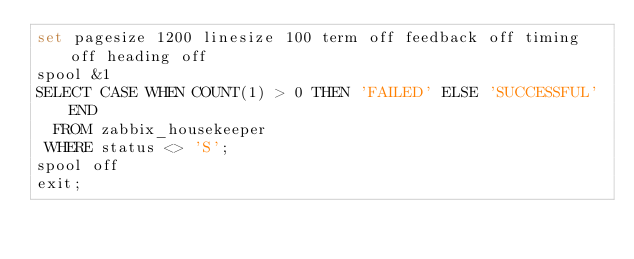Convert code to text. <code><loc_0><loc_0><loc_500><loc_500><_SQL_>set pagesize 1200 linesize 100 term off feedback off timing off heading off
spool &1
SELECT CASE WHEN COUNT(1) > 0 THEN 'FAILED' ELSE 'SUCCESSFUL' END 
  FROM zabbix_housekeeper
 WHERE status <> 'S';
spool off
exit;
</code> 